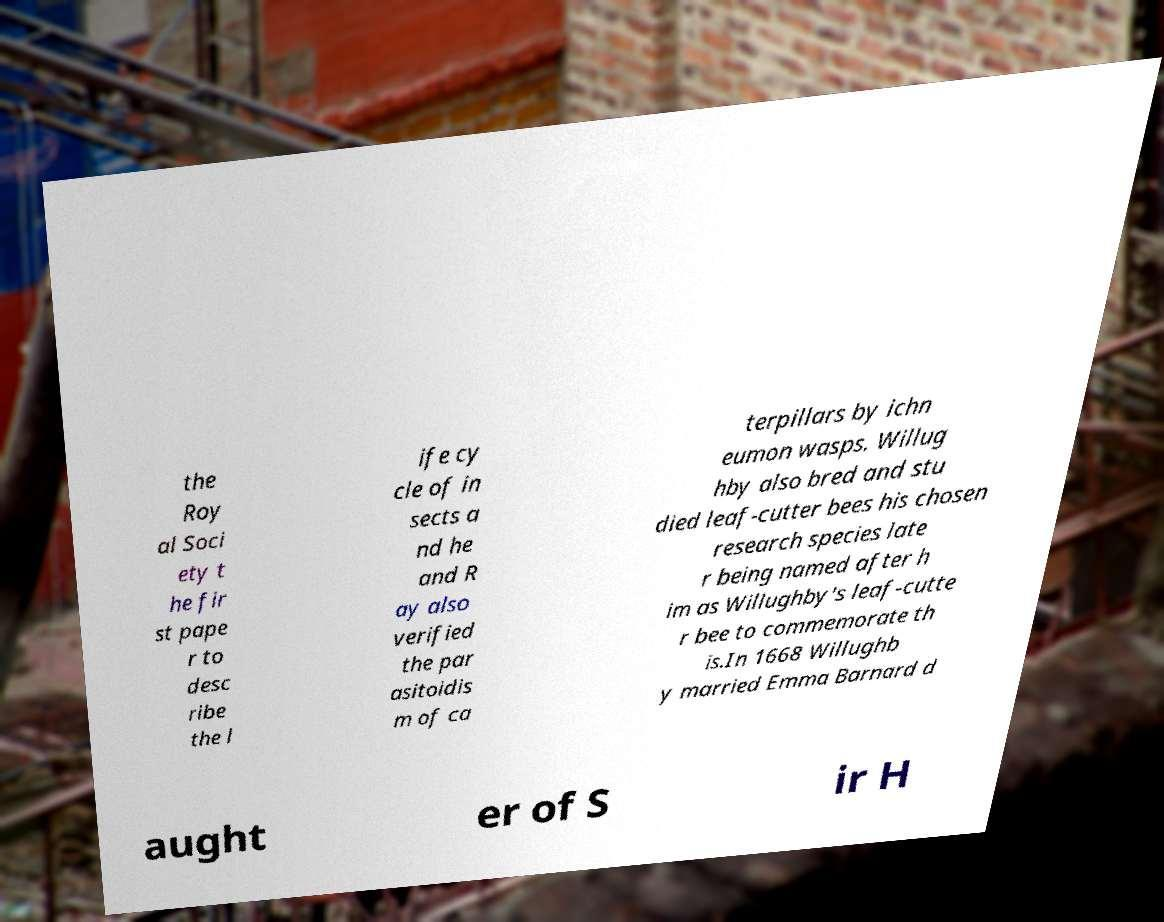Please read and relay the text visible in this image. What does it say? the Roy al Soci ety t he fir st pape r to desc ribe the l ife cy cle of in sects a nd he and R ay also verified the par asitoidis m of ca terpillars by ichn eumon wasps. Willug hby also bred and stu died leaf-cutter bees his chosen research species late r being named after h im as Willughby's leaf-cutte r bee to commemorate th is.In 1668 Willughb y married Emma Barnard d aught er of S ir H 